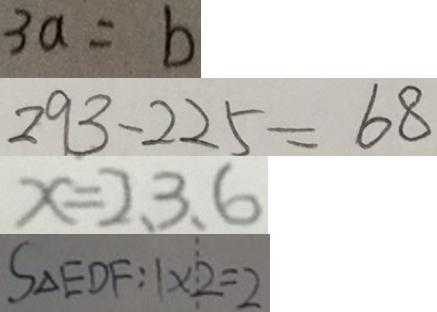<formula> <loc_0><loc_0><loc_500><loc_500>3 a = b 
 2 9 3 - 2 2 5 = 6 8 
 x = 2 、 3 、 6 
 S \Delta E D F : 1 \times 2 = 2</formula> 